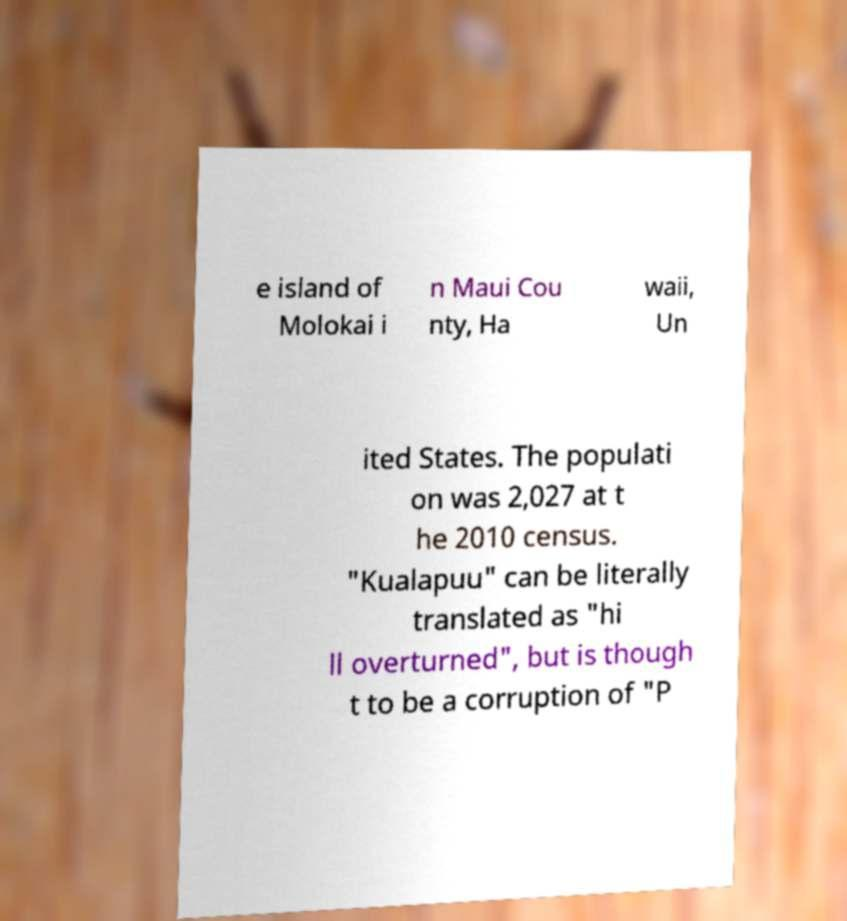I need the written content from this picture converted into text. Can you do that? e island of Molokai i n Maui Cou nty, Ha waii, Un ited States. The populati on was 2,027 at t he 2010 census. "Kualapuu" can be literally translated as "hi ll overturned", but is though t to be a corruption of "P 